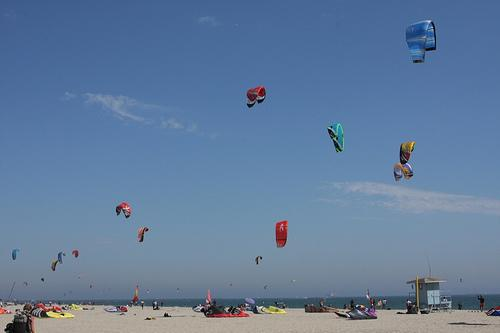What is the building for? lifeguard 